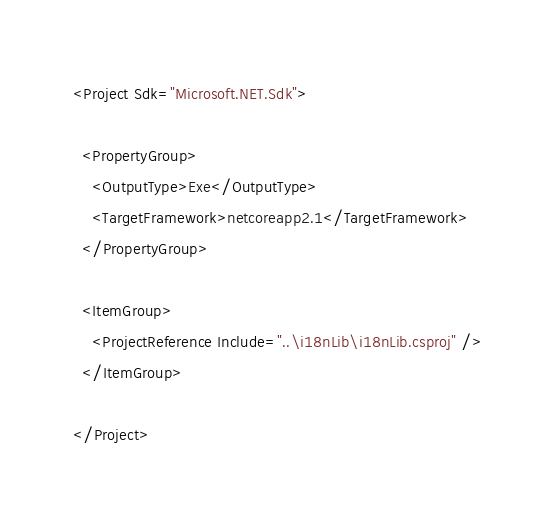<code> <loc_0><loc_0><loc_500><loc_500><_XML_><Project Sdk="Microsoft.NET.Sdk">

  <PropertyGroup>
    <OutputType>Exe</OutputType>
    <TargetFramework>netcoreapp2.1</TargetFramework>
  </PropertyGroup>

  <ItemGroup>
    <ProjectReference Include="..\i18nLib\i18nLib.csproj" />
  </ItemGroup>

</Project>
</code> 